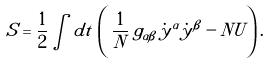Convert formula to latex. <formula><loc_0><loc_0><loc_500><loc_500>S = \frac { 1 } { 2 } \int d t \, \left ( \, \frac { 1 } { N } \, g _ { \alpha \beta } \, \dot { y } ^ { \alpha } \dot { y } ^ { \beta } - N U \right ) .</formula> 